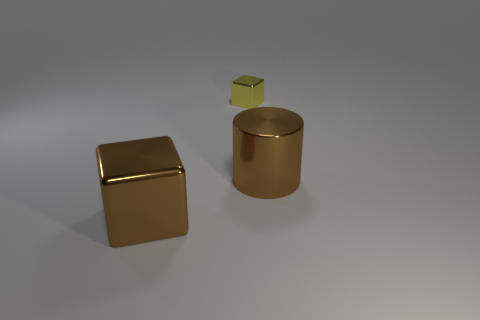Subtract 1 blocks. How many blocks are left? 1 Add 3 big brown blocks. How many objects exist? 6 Subtract all gray blocks. Subtract all yellow cylinders. How many blocks are left? 2 Subtract all red balls. How many red blocks are left? 0 Subtract all large metal cylinders. Subtract all brown cylinders. How many objects are left? 1 Add 3 small yellow blocks. How many small yellow blocks are left? 4 Add 1 small cyan metallic cubes. How many small cyan metallic cubes exist? 1 Subtract 1 brown cylinders. How many objects are left? 2 Subtract all cylinders. How many objects are left? 2 